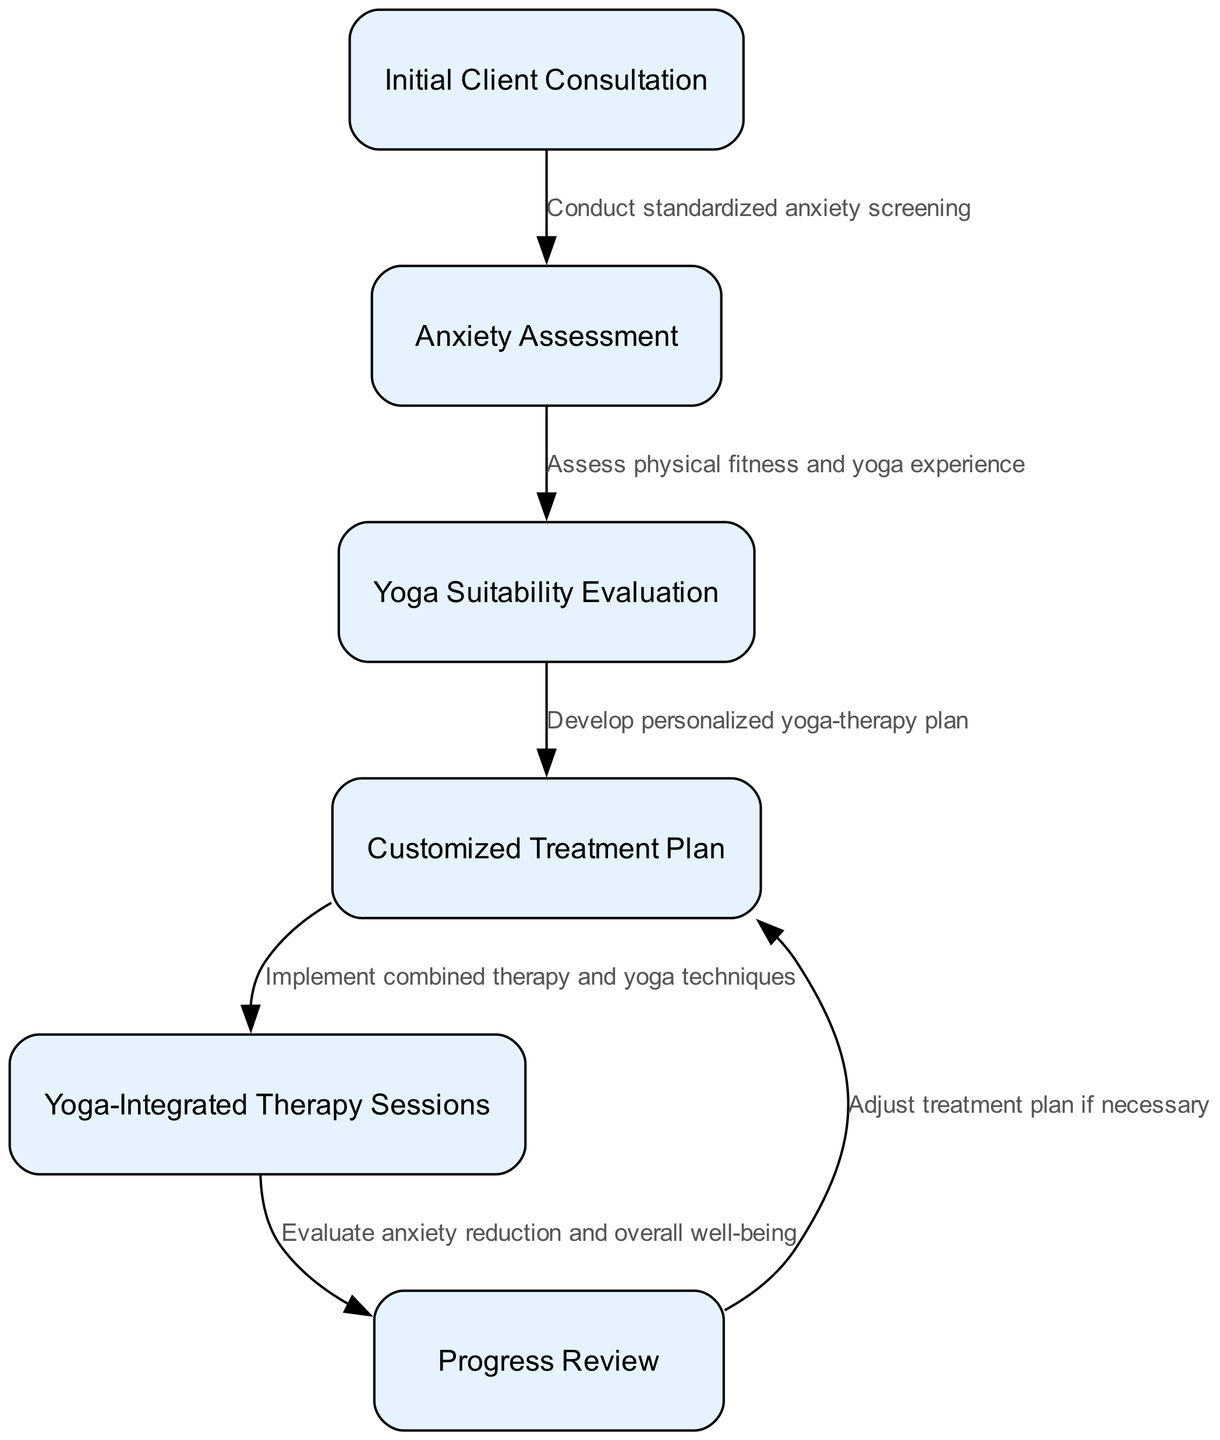What is the first step in the clinical pathway? The first step is "Initial Client Consultation," which is the starting point of the pathway where the therapist meets the client to discuss their needs.
Answer: Initial Client Consultation How many nodes are in the diagram? The diagram features a total of six nodes, each representing a distinct step or process related to anxiety clients and yoga therapy.
Answer: 6 What process follows the Anxiety Assessment? After the "Anxiety Assessment," the next step is "Yoga Suitability Evaluation," which determines the client’s fitness and previous experience with yoga.
Answer: Yoga Suitability Evaluation What is the relationship between the Customized Treatment Plan and Yoga-Integrated Therapy Sessions? The relationship is that the "Customized Treatment Plan" leads directly to the implementation of the "Yoga-Integrated Therapy Sessions," indicating the plan is put into action through these sessions.
Answer: Implement combined therapy and yoga techniques What happens during the Progress Review? During the "Progress Review," the focus is on evaluating anxiety reduction and overall well-being of the client after therapy sessions have been conducted.
Answer: Evaluate anxiety reduction and overall well-being How is the treatment plan adjusted? The treatment plan is adjusted if necessary during the "Progress Review," indicating that therapists may modify the plan based on the client's feedback and progress.
Answer: Adjust treatment plan if necessary What is conducted before the Yoga Suitability Evaluation? Before the "Yoga Suitability Evaluation," there is an "Anxiety Assessment," which is necessary to understand the client's mental health state and determine if they require yoga-integrated therapy.
Answer: Anxiety Assessment What leads to the creation of the Customized Treatment Plan? The "Yoga Suitability Evaluation" leads to the creation of the "Customized Treatment Plan," as it provides crucial information about the client that helps tailor the therapy accordingly.
Answer: Develop personalized yoga-therapy plan What is the final node in the clinical pathway? The final node in the clinical pathway is "Progress Review," where the therapist assesses the effectiveness of the therapy approach on the client's anxiety levels and wellness.
Answer: Progress Review 